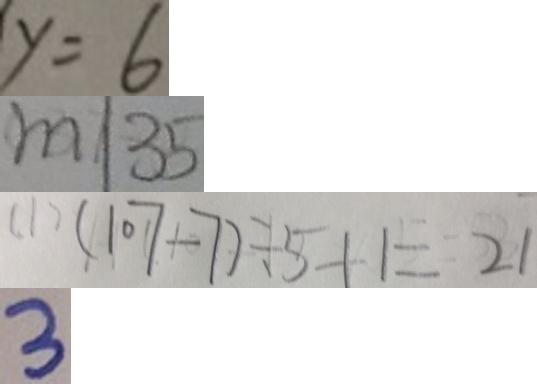<formula> <loc_0><loc_0><loc_500><loc_500>y = 6 
 m \vert 3 5 
 ( 1 ) ( 1 0 7 - 7 ) \div 5 + 1 = 2 1 
 3</formula> 